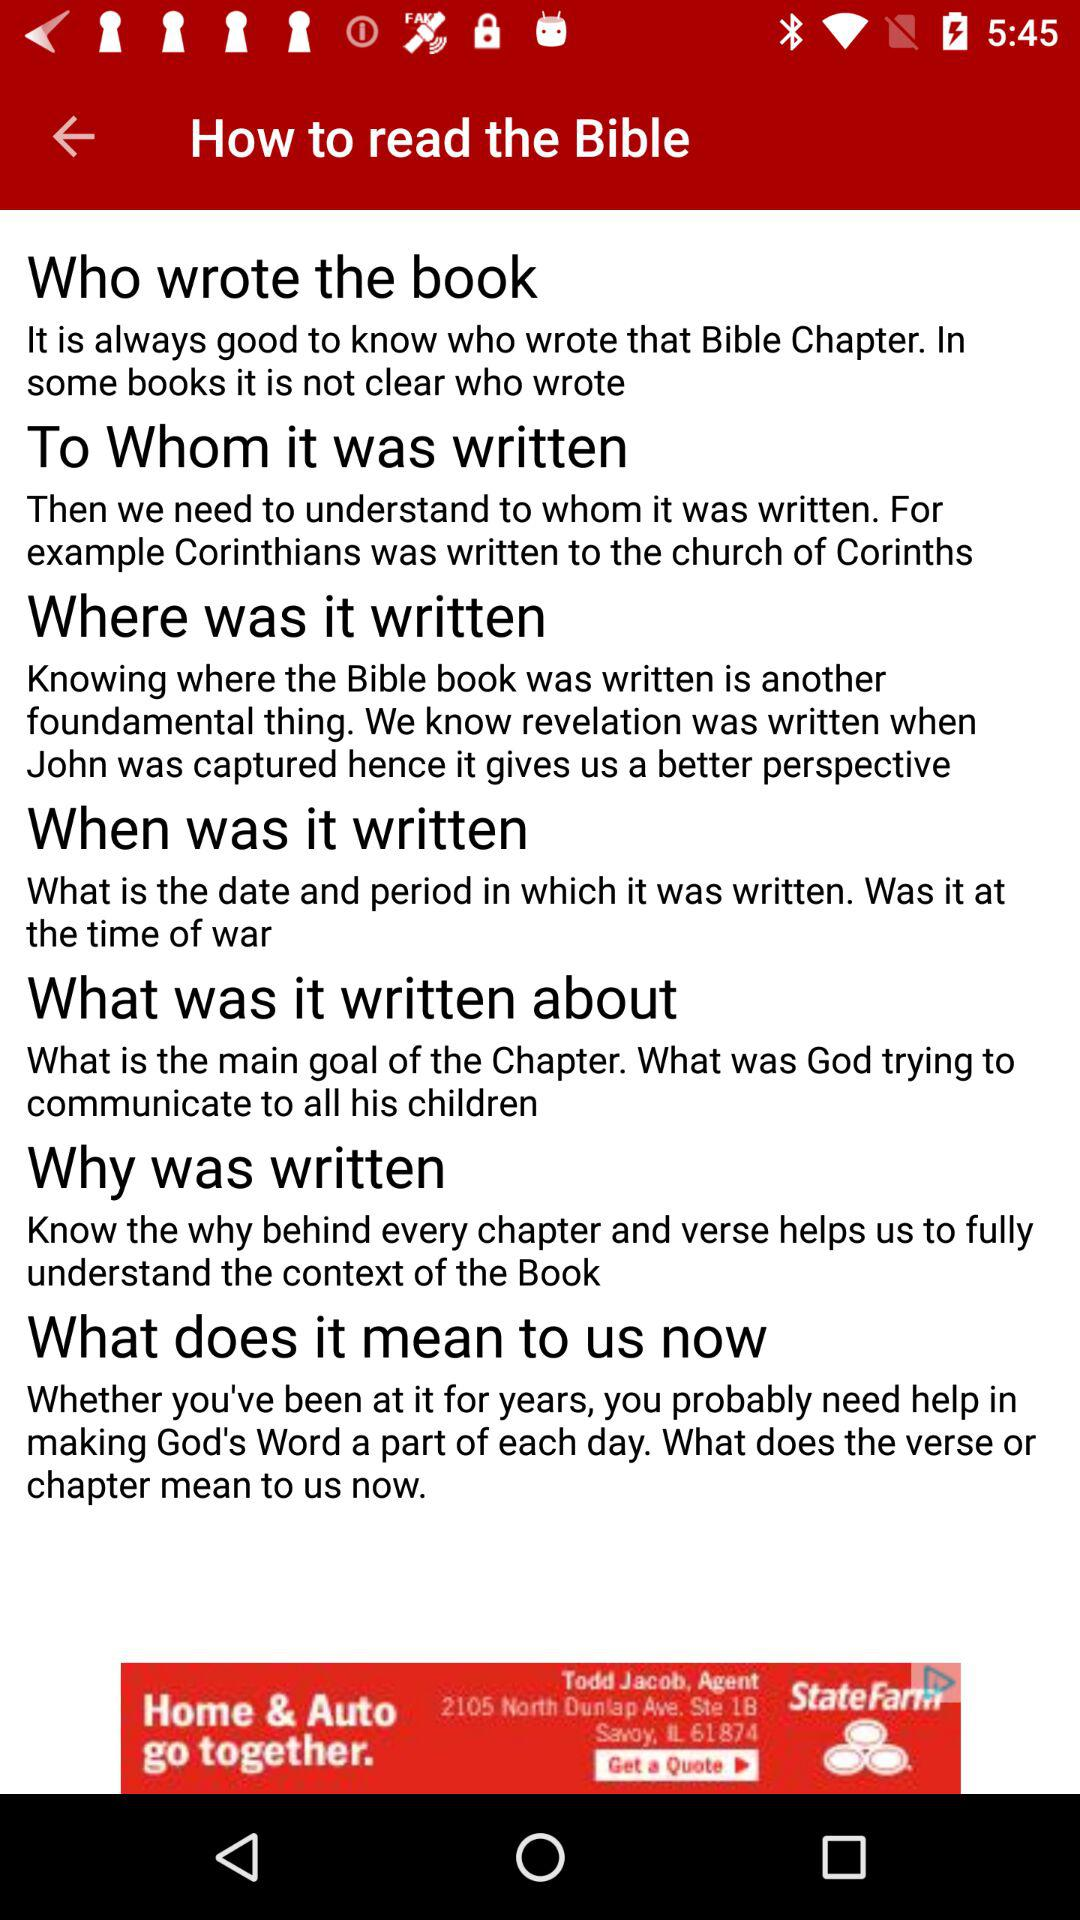How many steps are there to understanding the Bible?
Answer the question using a single word or phrase. 7 